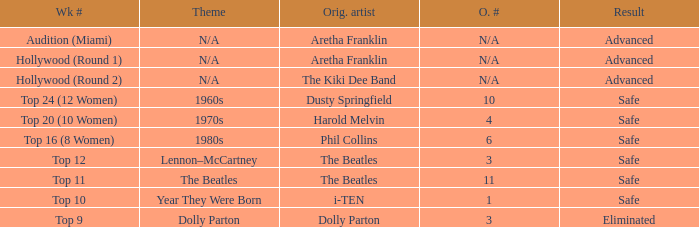Parse the table in full. {'header': ['Wk #', 'Theme', 'Orig. artist', 'O. #', 'Result'], 'rows': [['Audition (Miami)', 'N/A', 'Aretha Franklin', 'N/A', 'Advanced'], ['Hollywood (Round 1)', 'N/A', 'Aretha Franklin', 'N/A', 'Advanced'], ['Hollywood (Round 2)', 'N/A', 'The Kiki Dee Band', 'N/A', 'Advanced'], ['Top 24 (12 Women)', '1960s', 'Dusty Springfield', '10', 'Safe'], ['Top 20 (10 Women)', '1970s', 'Harold Melvin', '4', 'Safe'], ['Top 16 (8 Women)', '1980s', 'Phil Collins', '6', 'Safe'], ['Top 12', 'Lennon–McCartney', 'The Beatles', '3', 'Safe'], ['Top 11', 'The Beatles', 'The Beatles', '11', 'Safe'], ['Top 10', 'Year They Were Born', 'i-TEN', '1', 'Safe'], ['Top 9', 'Dolly Parton', 'Dolly Parton', '3', 'Eliminated']]} What is the original artist of top 9 as the week number? Dolly Parton. 